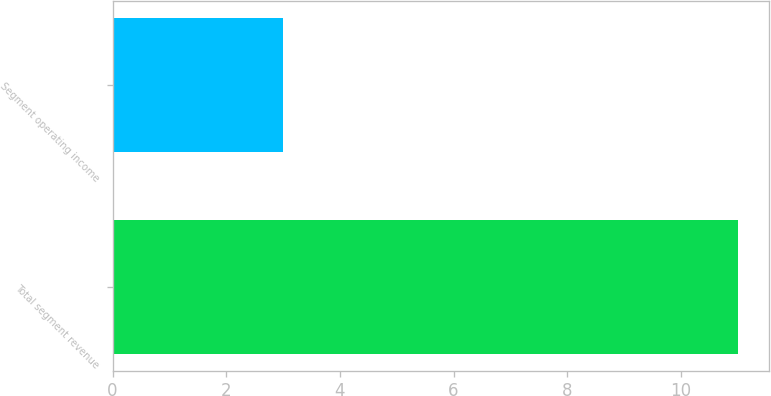Convert chart to OTSL. <chart><loc_0><loc_0><loc_500><loc_500><bar_chart><fcel>Total segment revenue<fcel>Segment operating income<nl><fcel>11<fcel>3<nl></chart> 